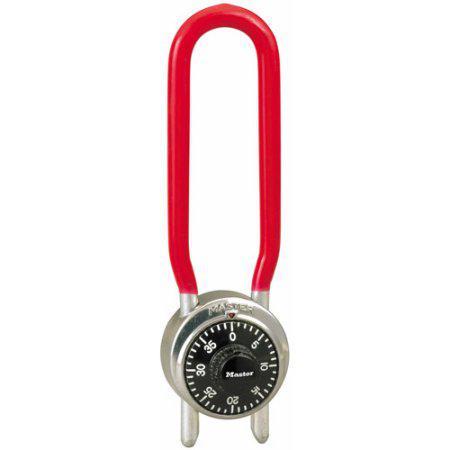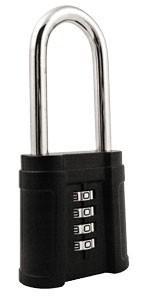The first image is the image on the left, the second image is the image on the right. For the images displayed, is the sentence "One lock is round with a black number dial, which the other is roughly square with four scrolling number belts." factually correct? Answer yes or no. Yes. The first image is the image on the left, the second image is the image on the right. Given the left and right images, does the statement "One of the locks is round in shape." hold true? Answer yes or no. Yes. 